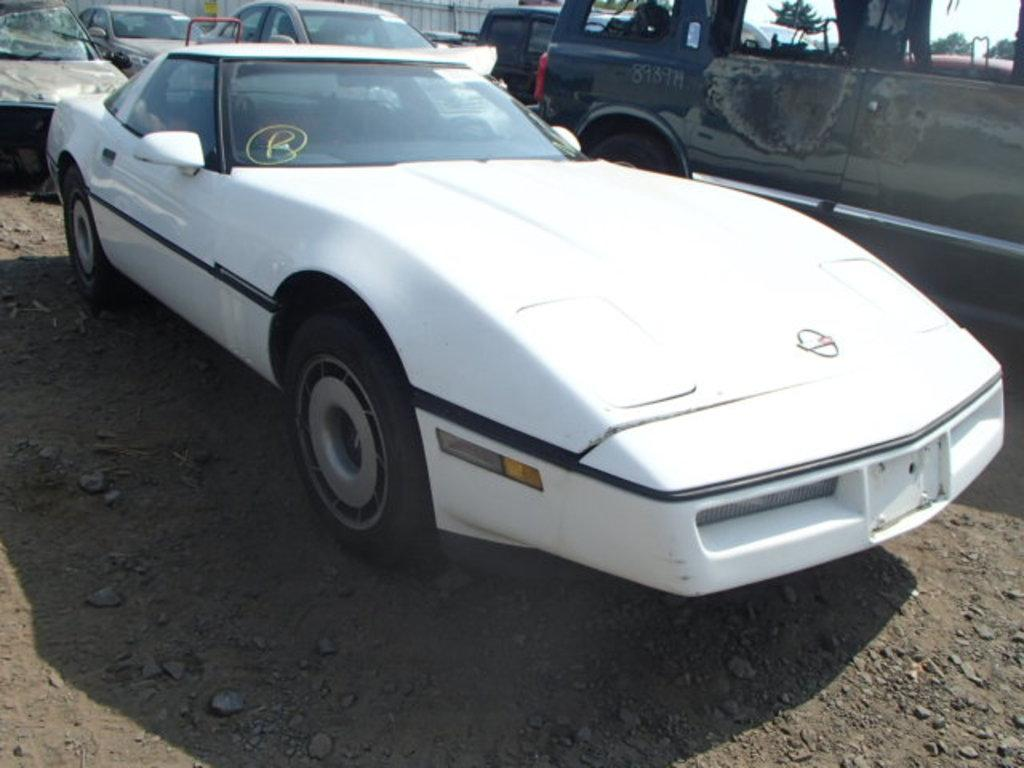What color is the car that is the main subject of the image? There is a white color car in the image. Can you describe the surrounding environment in the image? There are many cars visible behind the white car in the image. How much wax is needed to cover the cabbage in the image? There is no cabbage or wax present in the image. How many minutes does it take for the car to travel from one end of the image to the other? The image is a still photograph, so the car is not moving, and therefore the concept of time or minutes is not applicable. 